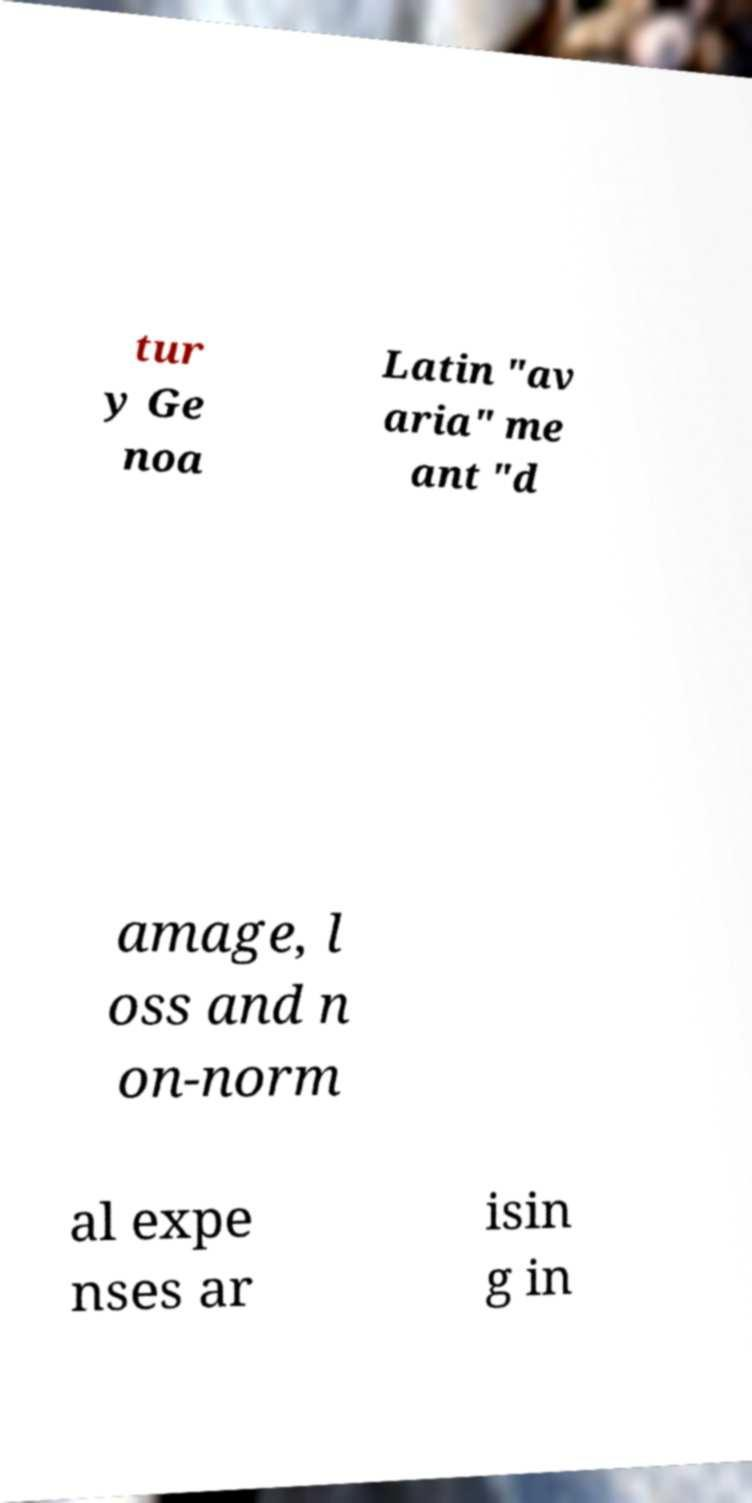I need the written content from this picture converted into text. Can you do that? tur y Ge noa Latin "av aria" me ant "d amage, l oss and n on-norm al expe nses ar isin g in 